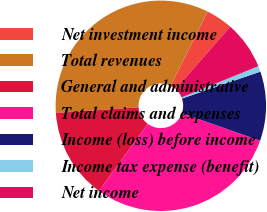Convert chart. <chart><loc_0><loc_0><loc_500><loc_500><pie_chart><fcel>Net investment income<fcel>Total revenues<fcel>General and administrative<fcel>Total claims and expenses<fcel>Income (loss) before income<fcel>Income tax expense (benefit)<fcel>Net income<nl><fcel>4.13%<fcel>33.43%<fcel>13.9%<fcel>29.63%<fcel>10.64%<fcel>0.88%<fcel>7.39%<nl></chart> 